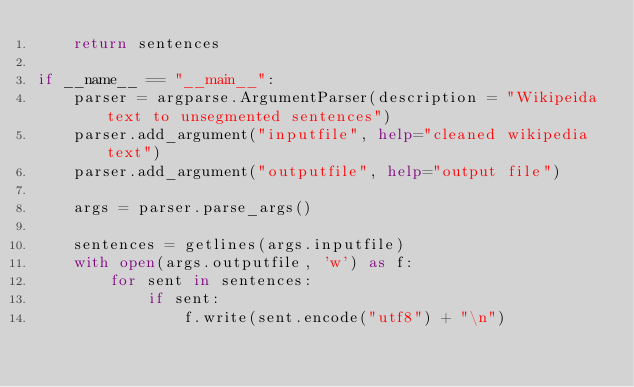<code> <loc_0><loc_0><loc_500><loc_500><_Python_>    return sentences

if __name__ == "__main__":
    parser = argparse.ArgumentParser(description = "Wikipeida text to unsegmented sentences")
    parser.add_argument("inputfile", help="cleaned wikipedia text")
    parser.add_argument("outputfile", help="output file")

    args = parser.parse_args()
    
    sentences = getlines(args.inputfile)
    with open(args.outputfile, 'w') as f:
        for sent in sentences:
            if sent:
                f.write(sent.encode("utf8") + "\n")
</code> 